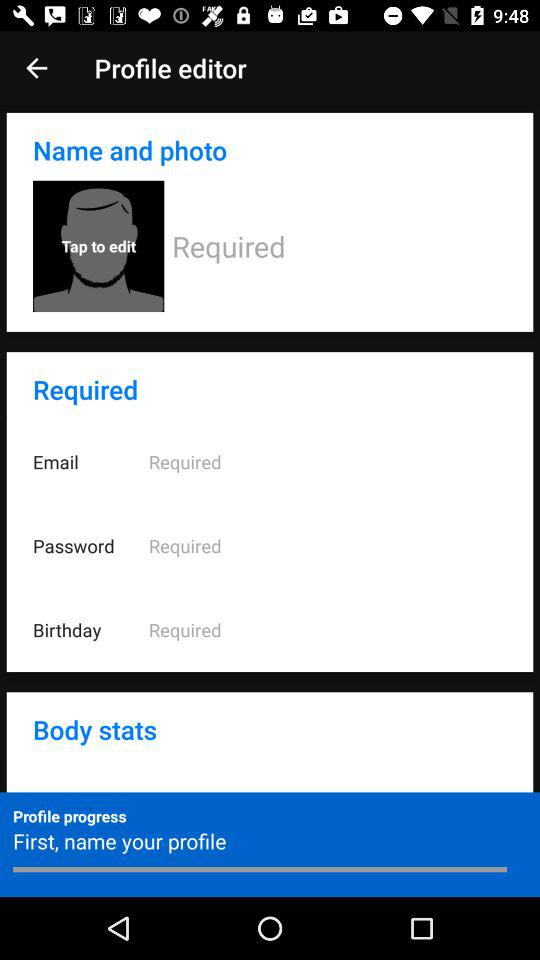Is there any section below 'Body stats' in the profile editor? The image cuts off after the 'Body stats' section and does not show if there are any additional sections below it. 